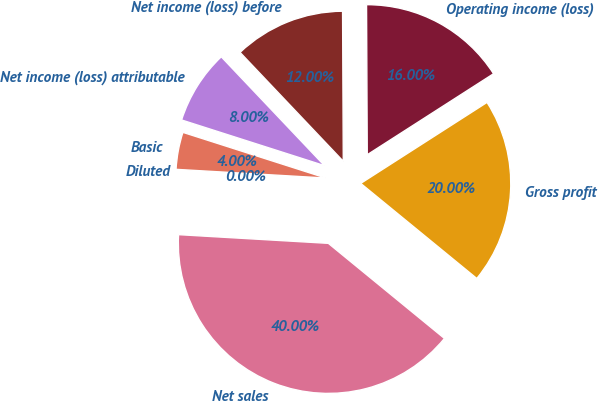Convert chart. <chart><loc_0><loc_0><loc_500><loc_500><pie_chart><fcel>Net sales<fcel>Gross profit<fcel>Operating income (loss)<fcel>Net income (loss) before<fcel>Net income (loss) attributable<fcel>Basic<fcel>Diluted<nl><fcel>40.0%<fcel>20.0%<fcel>16.0%<fcel>12.0%<fcel>8.0%<fcel>4.0%<fcel>0.0%<nl></chart> 